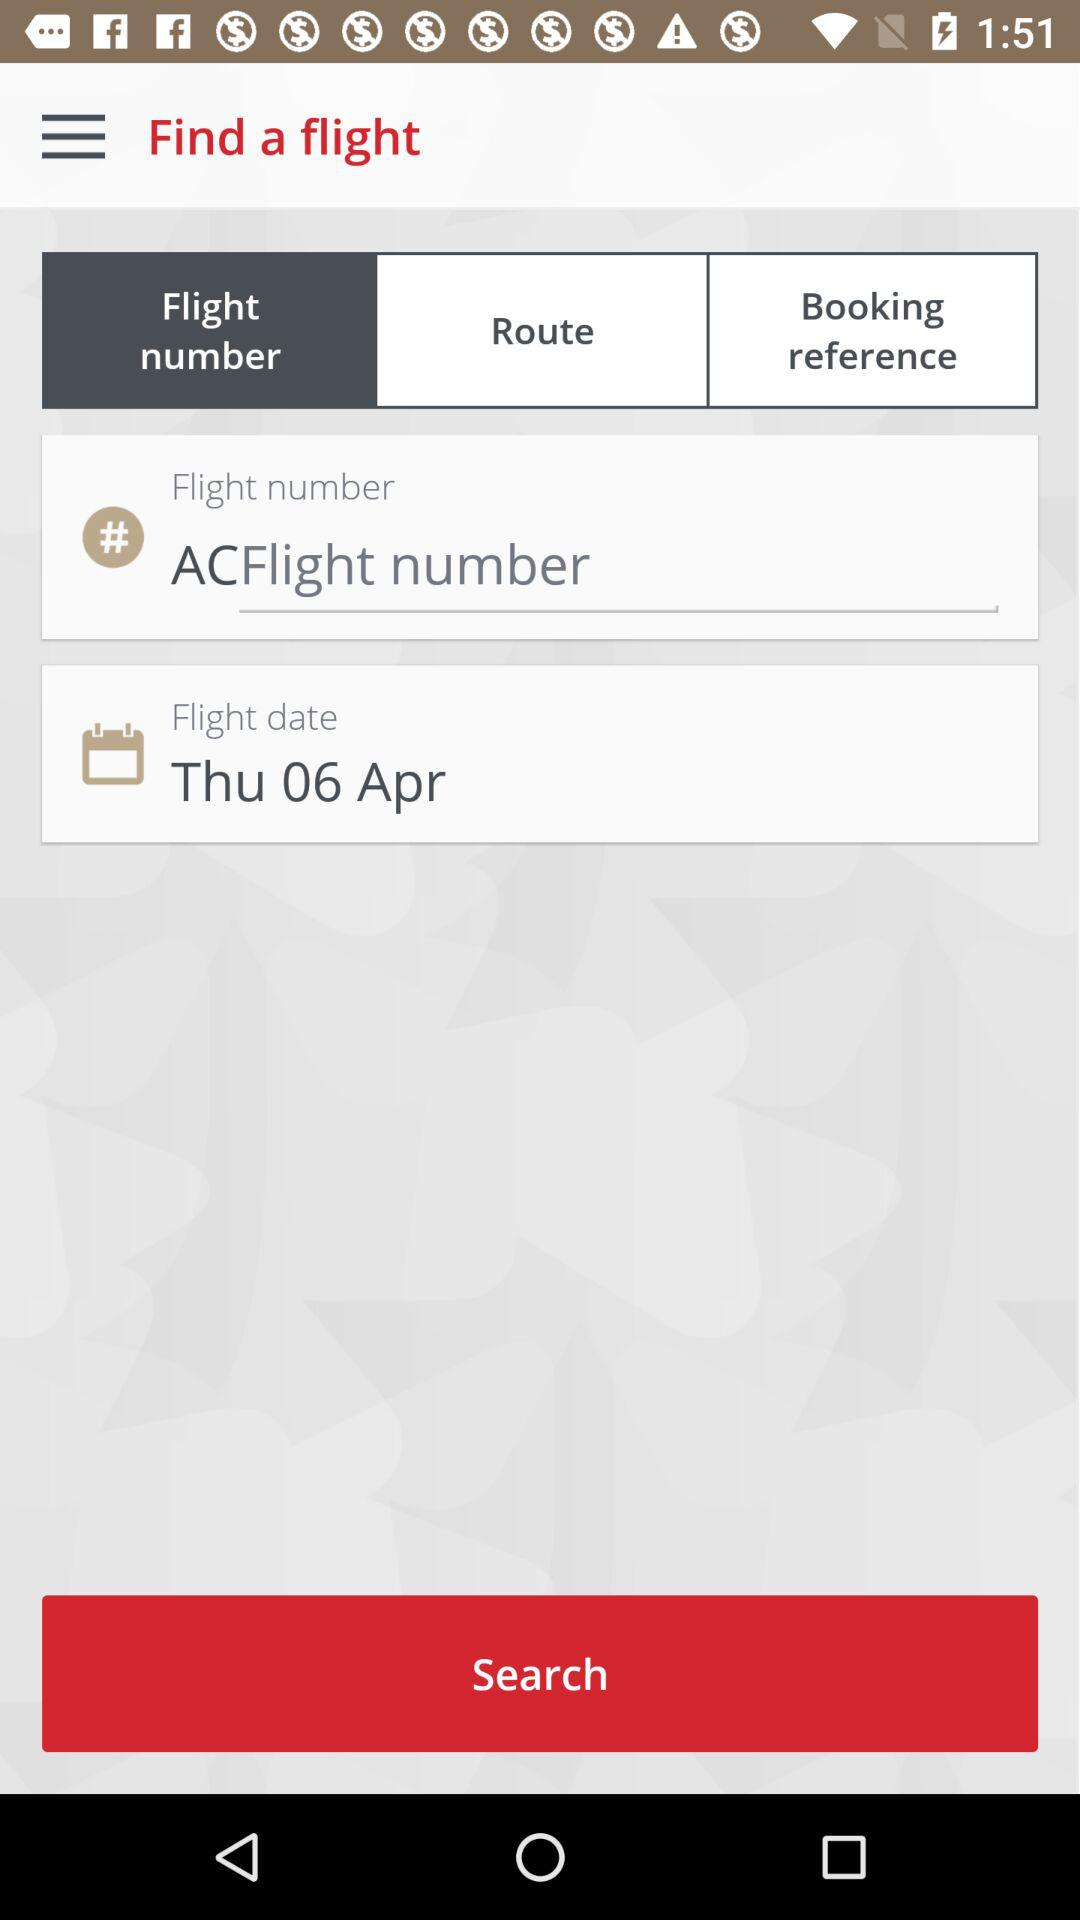Can I search for a flight using just the date and destination? Yes, typically, a basic flight search requires at least the departure and arrival destinations along with the date. Some interfaces, like the one in the image, allow for flexible search parameters and may even offer a simplified search using just these crucial details. 